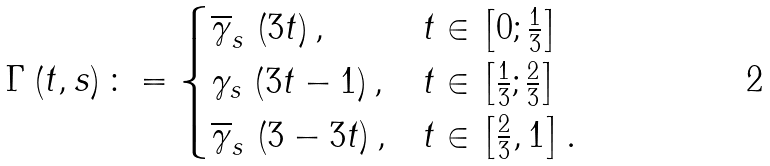<formula> <loc_0><loc_0><loc_500><loc_500>\Gamma \left ( t , s \right ) \colon = \begin{cases} \overline { \gamma } _ { s } \, \left ( 3 t \right ) , & t \in \left [ 0 ; \frac { 1 } 3 \right ] \\ \gamma _ { s } \, \left ( 3 t - 1 \right ) , & t \in \left [ \frac { 1 } 3 ; \frac { 2 } 3 \right ] \\ \overline { \gamma } _ { s } \, \left ( 3 - 3 t \right ) , & t \in \left [ \frac { 2 } 3 , 1 \right ] . \end{cases}</formula> 